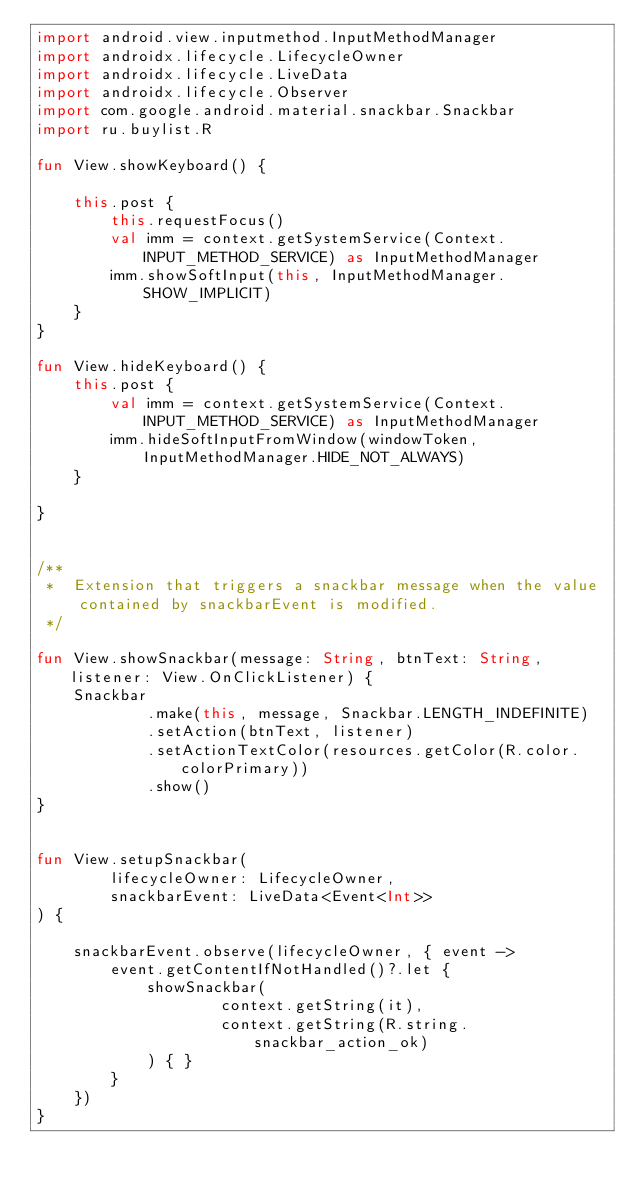Convert code to text. <code><loc_0><loc_0><loc_500><loc_500><_Kotlin_>import android.view.inputmethod.InputMethodManager
import androidx.lifecycle.LifecycleOwner
import androidx.lifecycle.LiveData
import androidx.lifecycle.Observer
import com.google.android.material.snackbar.Snackbar
import ru.buylist.R

fun View.showKeyboard() {

    this.post {
        this.requestFocus()
        val imm = context.getSystemService(Context.INPUT_METHOD_SERVICE) as InputMethodManager
        imm.showSoftInput(this, InputMethodManager.SHOW_IMPLICIT)
    }
}

fun View.hideKeyboard() {
    this.post {
        val imm = context.getSystemService(Context.INPUT_METHOD_SERVICE) as InputMethodManager
        imm.hideSoftInputFromWindow(windowToken, InputMethodManager.HIDE_NOT_ALWAYS)
    }

}


/**
 *  Extension that triggers a snackbar message when the value contained by snackbarEvent is modified.
 */

fun View.showSnackbar(message: String, btnText: String, listener: View.OnClickListener) {
    Snackbar
            .make(this, message, Snackbar.LENGTH_INDEFINITE)
            .setAction(btnText, listener)
            .setActionTextColor(resources.getColor(R.color.colorPrimary))
            .show()
}


fun View.setupSnackbar(
        lifecycleOwner: LifecycleOwner,
        snackbarEvent: LiveData<Event<Int>>
) {

    snackbarEvent.observe(lifecycleOwner, { event ->
        event.getContentIfNotHandled()?.let {
            showSnackbar(
                    context.getString(it),
                    context.getString(R.string.snackbar_action_ok)
            ) { }
        }
    })
}</code> 